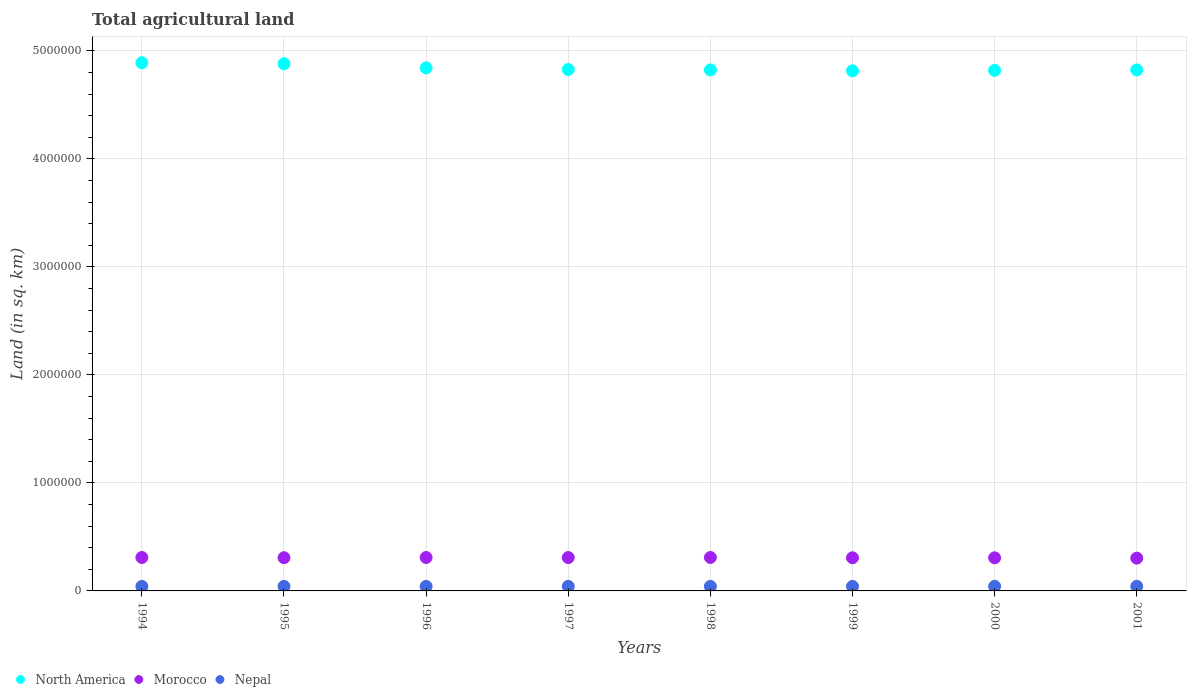How many different coloured dotlines are there?
Offer a terse response. 3. What is the total agricultural land in Nepal in 1997?
Offer a terse response. 4.21e+04. Across all years, what is the maximum total agricultural land in Morocco?
Offer a very short reply. 3.10e+05. Across all years, what is the minimum total agricultural land in Nepal?
Make the answer very short. 4.18e+04. What is the total total agricultural land in Morocco in the graph?
Ensure brevity in your answer.  2.46e+06. What is the difference between the total agricultural land in North America in 1996 and that in 1999?
Offer a very short reply. 2.75e+04. What is the difference between the total agricultural land in North America in 1994 and the total agricultural land in Nepal in 1996?
Your response must be concise. 4.85e+06. What is the average total agricultural land in Morocco per year?
Your answer should be compact. 3.08e+05. In the year 1998, what is the difference between the total agricultural land in North America and total agricultural land in Morocco?
Ensure brevity in your answer.  4.51e+06. What is the ratio of the total agricultural land in North America in 1995 to that in 1997?
Ensure brevity in your answer.  1.01. What is the difference between the highest and the second highest total agricultural land in Nepal?
Your response must be concise. 119. What is the difference between the highest and the lowest total agricultural land in North America?
Make the answer very short. 7.46e+04. In how many years, is the total agricultural land in Morocco greater than the average total agricultural land in Morocco taken over all years?
Provide a short and direct response. 4. Is the sum of the total agricultural land in Nepal in 1997 and 1999 greater than the maximum total agricultural land in North America across all years?
Make the answer very short. No. Is the total agricultural land in Morocco strictly greater than the total agricultural land in North America over the years?
Your response must be concise. No. How many years are there in the graph?
Your answer should be very brief. 8. What is the difference between two consecutive major ticks on the Y-axis?
Provide a short and direct response. 1.00e+06. Are the values on the major ticks of Y-axis written in scientific E-notation?
Your answer should be very brief. No. Does the graph contain grids?
Ensure brevity in your answer.  Yes. How are the legend labels stacked?
Provide a short and direct response. Horizontal. What is the title of the graph?
Ensure brevity in your answer.  Total agricultural land. Does "Qatar" appear as one of the legend labels in the graph?
Make the answer very short. No. What is the label or title of the X-axis?
Your answer should be compact. Years. What is the label or title of the Y-axis?
Keep it short and to the point. Land (in sq. km). What is the Land (in sq. km) of North America in 1994?
Provide a succinct answer. 4.89e+06. What is the Land (in sq. km) of Morocco in 1994?
Your answer should be very brief. 3.10e+05. What is the Land (in sq. km) in Nepal in 1994?
Ensure brevity in your answer.  4.18e+04. What is the Land (in sq. km) of North America in 1995?
Give a very brief answer. 4.88e+06. What is the Land (in sq. km) of Morocco in 1995?
Your answer should be compact. 3.07e+05. What is the Land (in sq. km) of Nepal in 1995?
Provide a short and direct response. 4.19e+04. What is the Land (in sq. km) of North America in 1996?
Your answer should be compact. 4.84e+06. What is the Land (in sq. km) in Morocco in 1996?
Keep it short and to the point. 3.10e+05. What is the Land (in sq. km) in Nepal in 1996?
Offer a very short reply. 4.20e+04. What is the Land (in sq. km) of North America in 1997?
Ensure brevity in your answer.  4.83e+06. What is the Land (in sq. km) in Morocco in 1997?
Offer a very short reply. 3.09e+05. What is the Land (in sq. km) in Nepal in 1997?
Provide a succinct answer. 4.21e+04. What is the Land (in sq. km) of North America in 1998?
Your answer should be very brief. 4.82e+06. What is the Land (in sq. km) of Morocco in 1998?
Give a very brief answer. 3.10e+05. What is the Land (in sq. km) of Nepal in 1998?
Your answer should be very brief. 4.23e+04. What is the Land (in sq. km) of North America in 1999?
Provide a short and direct response. 4.82e+06. What is the Land (in sq. km) of Morocco in 1999?
Make the answer very short. 3.07e+05. What is the Land (in sq. km) of Nepal in 1999?
Offer a very short reply. 4.24e+04. What is the Land (in sq. km) of North America in 2000?
Offer a very short reply. 4.82e+06. What is the Land (in sq. km) of Morocco in 2000?
Offer a terse response. 3.07e+05. What is the Land (in sq. km) in Nepal in 2000?
Your answer should be very brief. 4.25e+04. What is the Land (in sq. km) in North America in 2001?
Provide a short and direct response. 4.82e+06. What is the Land (in sq. km) in Morocco in 2001?
Your answer should be compact. 3.04e+05. What is the Land (in sq. km) of Nepal in 2001?
Your response must be concise. 4.26e+04. Across all years, what is the maximum Land (in sq. km) of North America?
Offer a very short reply. 4.89e+06. Across all years, what is the maximum Land (in sq. km) of Morocco?
Your answer should be compact. 3.10e+05. Across all years, what is the maximum Land (in sq. km) of Nepal?
Provide a succinct answer. 4.26e+04. Across all years, what is the minimum Land (in sq. km) of North America?
Make the answer very short. 4.82e+06. Across all years, what is the minimum Land (in sq. km) in Morocco?
Your answer should be compact. 3.04e+05. Across all years, what is the minimum Land (in sq. km) in Nepal?
Ensure brevity in your answer.  4.18e+04. What is the total Land (in sq. km) of North America in the graph?
Your answer should be very brief. 3.87e+07. What is the total Land (in sq. km) in Morocco in the graph?
Offer a terse response. 2.46e+06. What is the total Land (in sq. km) in Nepal in the graph?
Your answer should be very brief. 3.38e+05. What is the difference between the Land (in sq. km) in North America in 1994 and that in 1995?
Offer a terse response. 9399. What is the difference between the Land (in sq. km) of Morocco in 1994 and that in 1995?
Your answer should be very brief. 2150. What is the difference between the Land (in sq. km) in Nepal in 1994 and that in 1995?
Your answer should be very brief. -112. What is the difference between the Land (in sq. km) of North America in 1994 and that in 1996?
Provide a succinct answer. 4.71e+04. What is the difference between the Land (in sq. km) of Nepal in 1994 and that in 1996?
Offer a terse response. -224. What is the difference between the Land (in sq. km) in North America in 1994 and that in 1997?
Keep it short and to the point. 6.24e+04. What is the difference between the Land (in sq. km) of Morocco in 1994 and that in 1997?
Give a very brief answer. 690. What is the difference between the Land (in sq. km) of Nepal in 1994 and that in 1997?
Your answer should be very brief. -336. What is the difference between the Land (in sq. km) in North America in 1994 and that in 1998?
Your answer should be compact. 6.65e+04. What is the difference between the Land (in sq. km) in Morocco in 1994 and that in 1998?
Offer a very short reply. -120. What is the difference between the Land (in sq. km) in Nepal in 1994 and that in 1998?
Provide a succinct answer. -448. What is the difference between the Land (in sq. km) of North America in 1994 and that in 1999?
Your response must be concise. 7.46e+04. What is the difference between the Land (in sq. km) of Morocco in 1994 and that in 1999?
Your answer should be compact. 2710. What is the difference between the Land (in sq. km) of Nepal in 1994 and that in 1999?
Make the answer very short. -560. What is the difference between the Land (in sq. km) of North America in 1994 and that in 2000?
Offer a terse response. 7.06e+04. What is the difference between the Land (in sq. km) of Morocco in 1994 and that in 2000?
Keep it short and to the point. 3120. What is the difference between the Land (in sq. km) in Nepal in 1994 and that in 2000?
Make the answer very short. -685. What is the difference between the Land (in sq. km) in North America in 1994 and that in 2001?
Offer a very short reply. 6.63e+04. What is the difference between the Land (in sq. km) in Morocco in 1994 and that in 2001?
Offer a terse response. 5940. What is the difference between the Land (in sq. km) in Nepal in 1994 and that in 2001?
Your answer should be compact. -804. What is the difference between the Land (in sq. km) of North America in 1995 and that in 1996?
Offer a very short reply. 3.77e+04. What is the difference between the Land (in sq. km) of Morocco in 1995 and that in 1996?
Your answer should be very brief. -2170. What is the difference between the Land (in sq. km) in Nepal in 1995 and that in 1996?
Offer a terse response. -112. What is the difference between the Land (in sq. km) in North America in 1995 and that in 1997?
Your answer should be very brief. 5.30e+04. What is the difference between the Land (in sq. km) of Morocco in 1995 and that in 1997?
Offer a terse response. -1460. What is the difference between the Land (in sq. km) in Nepal in 1995 and that in 1997?
Your answer should be compact. -224. What is the difference between the Land (in sq. km) in North America in 1995 and that in 1998?
Ensure brevity in your answer.  5.71e+04. What is the difference between the Land (in sq. km) of Morocco in 1995 and that in 1998?
Offer a terse response. -2270. What is the difference between the Land (in sq. km) in Nepal in 1995 and that in 1998?
Give a very brief answer. -336. What is the difference between the Land (in sq. km) in North America in 1995 and that in 1999?
Provide a succinct answer. 6.52e+04. What is the difference between the Land (in sq. km) of Morocco in 1995 and that in 1999?
Offer a very short reply. 560. What is the difference between the Land (in sq. km) of Nepal in 1995 and that in 1999?
Ensure brevity in your answer.  -448. What is the difference between the Land (in sq. km) in North America in 1995 and that in 2000?
Offer a terse response. 6.12e+04. What is the difference between the Land (in sq. km) of Morocco in 1995 and that in 2000?
Make the answer very short. 970. What is the difference between the Land (in sq. km) of Nepal in 1995 and that in 2000?
Provide a short and direct response. -573. What is the difference between the Land (in sq. km) of North America in 1995 and that in 2001?
Ensure brevity in your answer.  5.69e+04. What is the difference between the Land (in sq. km) of Morocco in 1995 and that in 2001?
Ensure brevity in your answer.  3790. What is the difference between the Land (in sq. km) in Nepal in 1995 and that in 2001?
Give a very brief answer. -692. What is the difference between the Land (in sq. km) of North America in 1996 and that in 1997?
Offer a very short reply. 1.53e+04. What is the difference between the Land (in sq. km) of Morocco in 1996 and that in 1997?
Provide a succinct answer. 710. What is the difference between the Land (in sq. km) of Nepal in 1996 and that in 1997?
Your answer should be compact. -112. What is the difference between the Land (in sq. km) in North America in 1996 and that in 1998?
Provide a short and direct response. 1.94e+04. What is the difference between the Land (in sq. km) in Morocco in 1996 and that in 1998?
Your answer should be compact. -100. What is the difference between the Land (in sq. km) of Nepal in 1996 and that in 1998?
Your answer should be very brief. -224. What is the difference between the Land (in sq. km) in North America in 1996 and that in 1999?
Make the answer very short. 2.75e+04. What is the difference between the Land (in sq. km) of Morocco in 1996 and that in 1999?
Your response must be concise. 2730. What is the difference between the Land (in sq. km) in Nepal in 1996 and that in 1999?
Offer a very short reply. -336. What is the difference between the Land (in sq. km) of North America in 1996 and that in 2000?
Your answer should be very brief. 2.35e+04. What is the difference between the Land (in sq. km) in Morocco in 1996 and that in 2000?
Offer a terse response. 3140. What is the difference between the Land (in sq. km) in Nepal in 1996 and that in 2000?
Keep it short and to the point. -461. What is the difference between the Land (in sq. km) of North America in 1996 and that in 2001?
Ensure brevity in your answer.  1.92e+04. What is the difference between the Land (in sq. km) in Morocco in 1996 and that in 2001?
Give a very brief answer. 5960. What is the difference between the Land (in sq. km) of Nepal in 1996 and that in 2001?
Offer a terse response. -580. What is the difference between the Land (in sq. km) of North America in 1997 and that in 1998?
Make the answer very short. 4070. What is the difference between the Land (in sq. km) of Morocco in 1997 and that in 1998?
Make the answer very short. -810. What is the difference between the Land (in sq. km) in Nepal in 1997 and that in 1998?
Provide a succinct answer. -112. What is the difference between the Land (in sq. km) in North America in 1997 and that in 1999?
Keep it short and to the point. 1.22e+04. What is the difference between the Land (in sq. km) in Morocco in 1997 and that in 1999?
Your answer should be very brief. 2020. What is the difference between the Land (in sq. km) of Nepal in 1997 and that in 1999?
Provide a short and direct response. -224. What is the difference between the Land (in sq. km) in North America in 1997 and that in 2000?
Provide a short and direct response. 8170. What is the difference between the Land (in sq. km) of Morocco in 1997 and that in 2000?
Make the answer very short. 2430. What is the difference between the Land (in sq. km) in Nepal in 1997 and that in 2000?
Your answer should be very brief. -349. What is the difference between the Land (in sq. km) in North America in 1997 and that in 2001?
Offer a terse response. 3830. What is the difference between the Land (in sq. km) of Morocco in 1997 and that in 2001?
Provide a succinct answer. 5250. What is the difference between the Land (in sq. km) in Nepal in 1997 and that in 2001?
Your response must be concise. -468. What is the difference between the Land (in sq. km) in North America in 1998 and that in 1999?
Provide a succinct answer. 8120. What is the difference between the Land (in sq. km) of Morocco in 1998 and that in 1999?
Ensure brevity in your answer.  2830. What is the difference between the Land (in sq. km) of Nepal in 1998 and that in 1999?
Provide a succinct answer. -112. What is the difference between the Land (in sq. km) in North America in 1998 and that in 2000?
Keep it short and to the point. 4100. What is the difference between the Land (in sq. km) in Morocco in 1998 and that in 2000?
Provide a succinct answer. 3240. What is the difference between the Land (in sq. km) of Nepal in 1998 and that in 2000?
Ensure brevity in your answer.  -237. What is the difference between the Land (in sq. km) of North America in 1998 and that in 2001?
Give a very brief answer. -240. What is the difference between the Land (in sq. km) of Morocco in 1998 and that in 2001?
Provide a succinct answer. 6060. What is the difference between the Land (in sq. km) in Nepal in 1998 and that in 2001?
Offer a terse response. -356. What is the difference between the Land (in sq. km) in North America in 1999 and that in 2000?
Give a very brief answer. -4020. What is the difference between the Land (in sq. km) of Morocco in 1999 and that in 2000?
Give a very brief answer. 410. What is the difference between the Land (in sq. km) of Nepal in 1999 and that in 2000?
Offer a terse response. -125. What is the difference between the Land (in sq. km) of North America in 1999 and that in 2001?
Offer a very short reply. -8360. What is the difference between the Land (in sq. km) in Morocco in 1999 and that in 2001?
Offer a very short reply. 3230. What is the difference between the Land (in sq. km) of Nepal in 1999 and that in 2001?
Ensure brevity in your answer.  -244. What is the difference between the Land (in sq. km) of North America in 2000 and that in 2001?
Give a very brief answer. -4340. What is the difference between the Land (in sq. km) of Morocco in 2000 and that in 2001?
Offer a very short reply. 2820. What is the difference between the Land (in sq. km) of Nepal in 2000 and that in 2001?
Ensure brevity in your answer.  -119. What is the difference between the Land (in sq. km) of North America in 1994 and the Land (in sq. km) of Morocco in 1995?
Ensure brevity in your answer.  4.58e+06. What is the difference between the Land (in sq. km) in North America in 1994 and the Land (in sq. km) in Nepal in 1995?
Your response must be concise. 4.85e+06. What is the difference between the Land (in sq. km) of Morocco in 1994 and the Land (in sq. km) of Nepal in 1995?
Offer a very short reply. 2.68e+05. What is the difference between the Land (in sq. km) of North America in 1994 and the Land (in sq. km) of Morocco in 1996?
Offer a very short reply. 4.58e+06. What is the difference between the Land (in sq. km) of North America in 1994 and the Land (in sq. km) of Nepal in 1996?
Offer a terse response. 4.85e+06. What is the difference between the Land (in sq. km) of Morocco in 1994 and the Land (in sq. km) of Nepal in 1996?
Offer a very short reply. 2.68e+05. What is the difference between the Land (in sq. km) of North America in 1994 and the Land (in sq. km) of Morocco in 1997?
Offer a very short reply. 4.58e+06. What is the difference between the Land (in sq. km) of North America in 1994 and the Land (in sq. km) of Nepal in 1997?
Provide a succinct answer. 4.85e+06. What is the difference between the Land (in sq. km) of Morocco in 1994 and the Land (in sq. km) of Nepal in 1997?
Keep it short and to the point. 2.67e+05. What is the difference between the Land (in sq. km) of North America in 1994 and the Land (in sq. km) of Morocco in 1998?
Provide a succinct answer. 4.58e+06. What is the difference between the Land (in sq. km) of North America in 1994 and the Land (in sq. km) of Nepal in 1998?
Your answer should be very brief. 4.85e+06. What is the difference between the Land (in sq. km) in Morocco in 1994 and the Land (in sq. km) in Nepal in 1998?
Your response must be concise. 2.67e+05. What is the difference between the Land (in sq. km) in North America in 1994 and the Land (in sq. km) in Morocco in 1999?
Offer a very short reply. 4.58e+06. What is the difference between the Land (in sq. km) of North America in 1994 and the Land (in sq. km) of Nepal in 1999?
Your answer should be very brief. 4.85e+06. What is the difference between the Land (in sq. km) in Morocco in 1994 and the Land (in sq. km) in Nepal in 1999?
Ensure brevity in your answer.  2.67e+05. What is the difference between the Land (in sq. km) of North America in 1994 and the Land (in sq. km) of Morocco in 2000?
Offer a terse response. 4.58e+06. What is the difference between the Land (in sq. km) of North America in 1994 and the Land (in sq. km) of Nepal in 2000?
Offer a very short reply. 4.85e+06. What is the difference between the Land (in sq. km) of Morocco in 1994 and the Land (in sq. km) of Nepal in 2000?
Give a very brief answer. 2.67e+05. What is the difference between the Land (in sq. km) in North America in 1994 and the Land (in sq. km) in Morocco in 2001?
Ensure brevity in your answer.  4.59e+06. What is the difference between the Land (in sq. km) in North America in 1994 and the Land (in sq. km) in Nepal in 2001?
Give a very brief answer. 4.85e+06. What is the difference between the Land (in sq. km) of Morocco in 1994 and the Land (in sq. km) of Nepal in 2001?
Offer a terse response. 2.67e+05. What is the difference between the Land (in sq. km) in North America in 1995 and the Land (in sq. km) in Morocco in 1996?
Ensure brevity in your answer.  4.57e+06. What is the difference between the Land (in sq. km) of North America in 1995 and the Land (in sq. km) of Nepal in 1996?
Give a very brief answer. 4.84e+06. What is the difference between the Land (in sq. km) in Morocco in 1995 and the Land (in sq. km) in Nepal in 1996?
Your answer should be compact. 2.65e+05. What is the difference between the Land (in sq. km) in North America in 1995 and the Land (in sq. km) in Morocco in 1997?
Ensure brevity in your answer.  4.57e+06. What is the difference between the Land (in sq. km) of North America in 1995 and the Land (in sq. km) of Nepal in 1997?
Offer a very short reply. 4.84e+06. What is the difference between the Land (in sq. km) of Morocco in 1995 and the Land (in sq. km) of Nepal in 1997?
Your answer should be compact. 2.65e+05. What is the difference between the Land (in sq. km) in North America in 1995 and the Land (in sq. km) in Morocco in 1998?
Offer a terse response. 4.57e+06. What is the difference between the Land (in sq. km) of North America in 1995 and the Land (in sq. km) of Nepal in 1998?
Your response must be concise. 4.84e+06. What is the difference between the Land (in sq. km) in Morocco in 1995 and the Land (in sq. km) in Nepal in 1998?
Your answer should be compact. 2.65e+05. What is the difference between the Land (in sq. km) of North America in 1995 and the Land (in sq. km) of Morocco in 1999?
Offer a very short reply. 4.57e+06. What is the difference between the Land (in sq. km) of North America in 1995 and the Land (in sq. km) of Nepal in 1999?
Your response must be concise. 4.84e+06. What is the difference between the Land (in sq. km) of Morocco in 1995 and the Land (in sq. km) of Nepal in 1999?
Ensure brevity in your answer.  2.65e+05. What is the difference between the Land (in sq. km) of North America in 1995 and the Land (in sq. km) of Morocco in 2000?
Make the answer very short. 4.57e+06. What is the difference between the Land (in sq. km) in North America in 1995 and the Land (in sq. km) in Nepal in 2000?
Your response must be concise. 4.84e+06. What is the difference between the Land (in sq. km) in Morocco in 1995 and the Land (in sq. km) in Nepal in 2000?
Ensure brevity in your answer.  2.65e+05. What is the difference between the Land (in sq. km) in North America in 1995 and the Land (in sq. km) in Morocco in 2001?
Ensure brevity in your answer.  4.58e+06. What is the difference between the Land (in sq. km) in North America in 1995 and the Land (in sq. km) in Nepal in 2001?
Keep it short and to the point. 4.84e+06. What is the difference between the Land (in sq. km) of Morocco in 1995 and the Land (in sq. km) of Nepal in 2001?
Make the answer very short. 2.65e+05. What is the difference between the Land (in sq. km) of North America in 1996 and the Land (in sq. km) of Morocco in 1997?
Give a very brief answer. 4.53e+06. What is the difference between the Land (in sq. km) in North America in 1996 and the Land (in sq. km) in Nepal in 1997?
Provide a succinct answer. 4.80e+06. What is the difference between the Land (in sq. km) in Morocco in 1996 and the Land (in sq. km) in Nepal in 1997?
Your answer should be very brief. 2.68e+05. What is the difference between the Land (in sq. km) in North America in 1996 and the Land (in sq. km) in Morocco in 1998?
Your answer should be compact. 4.53e+06. What is the difference between the Land (in sq. km) in North America in 1996 and the Land (in sq. km) in Nepal in 1998?
Your answer should be compact. 4.80e+06. What is the difference between the Land (in sq. km) in Morocco in 1996 and the Land (in sq. km) in Nepal in 1998?
Keep it short and to the point. 2.67e+05. What is the difference between the Land (in sq. km) of North America in 1996 and the Land (in sq. km) of Morocco in 1999?
Your answer should be very brief. 4.54e+06. What is the difference between the Land (in sq. km) of North America in 1996 and the Land (in sq. km) of Nepal in 1999?
Make the answer very short. 4.80e+06. What is the difference between the Land (in sq. km) of Morocco in 1996 and the Land (in sq. km) of Nepal in 1999?
Your answer should be very brief. 2.67e+05. What is the difference between the Land (in sq. km) of North America in 1996 and the Land (in sq. km) of Morocco in 2000?
Keep it short and to the point. 4.54e+06. What is the difference between the Land (in sq. km) of North America in 1996 and the Land (in sq. km) of Nepal in 2000?
Ensure brevity in your answer.  4.80e+06. What is the difference between the Land (in sq. km) in Morocco in 1996 and the Land (in sq. km) in Nepal in 2000?
Your answer should be compact. 2.67e+05. What is the difference between the Land (in sq. km) in North America in 1996 and the Land (in sq. km) in Morocco in 2001?
Your answer should be compact. 4.54e+06. What is the difference between the Land (in sq. km) of North America in 1996 and the Land (in sq. km) of Nepal in 2001?
Ensure brevity in your answer.  4.80e+06. What is the difference between the Land (in sq. km) of Morocco in 1996 and the Land (in sq. km) of Nepal in 2001?
Offer a terse response. 2.67e+05. What is the difference between the Land (in sq. km) in North America in 1997 and the Land (in sq. km) in Morocco in 1998?
Keep it short and to the point. 4.52e+06. What is the difference between the Land (in sq. km) of North America in 1997 and the Land (in sq. km) of Nepal in 1998?
Your response must be concise. 4.79e+06. What is the difference between the Land (in sq. km) of Morocco in 1997 and the Land (in sq. km) of Nepal in 1998?
Give a very brief answer. 2.67e+05. What is the difference between the Land (in sq. km) of North America in 1997 and the Land (in sq. km) of Morocco in 1999?
Your answer should be very brief. 4.52e+06. What is the difference between the Land (in sq. km) in North America in 1997 and the Land (in sq. km) in Nepal in 1999?
Your response must be concise. 4.79e+06. What is the difference between the Land (in sq. km) of Morocco in 1997 and the Land (in sq. km) of Nepal in 1999?
Keep it short and to the point. 2.67e+05. What is the difference between the Land (in sq. km) of North America in 1997 and the Land (in sq. km) of Morocco in 2000?
Keep it short and to the point. 4.52e+06. What is the difference between the Land (in sq. km) in North America in 1997 and the Land (in sq. km) in Nepal in 2000?
Offer a terse response. 4.79e+06. What is the difference between the Land (in sq. km) in Morocco in 1997 and the Land (in sq. km) in Nepal in 2000?
Offer a very short reply. 2.66e+05. What is the difference between the Land (in sq. km) in North America in 1997 and the Land (in sq. km) in Morocco in 2001?
Your answer should be compact. 4.52e+06. What is the difference between the Land (in sq. km) in North America in 1997 and the Land (in sq. km) in Nepal in 2001?
Give a very brief answer. 4.79e+06. What is the difference between the Land (in sq. km) in Morocco in 1997 and the Land (in sq. km) in Nepal in 2001?
Ensure brevity in your answer.  2.66e+05. What is the difference between the Land (in sq. km) in North America in 1998 and the Land (in sq. km) in Morocco in 1999?
Give a very brief answer. 4.52e+06. What is the difference between the Land (in sq. km) of North America in 1998 and the Land (in sq. km) of Nepal in 1999?
Ensure brevity in your answer.  4.78e+06. What is the difference between the Land (in sq. km) of Morocco in 1998 and the Land (in sq. km) of Nepal in 1999?
Give a very brief answer. 2.67e+05. What is the difference between the Land (in sq. km) of North America in 1998 and the Land (in sq. km) of Morocco in 2000?
Offer a very short reply. 4.52e+06. What is the difference between the Land (in sq. km) in North America in 1998 and the Land (in sq. km) in Nepal in 2000?
Keep it short and to the point. 4.78e+06. What is the difference between the Land (in sq. km) in Morocco in 1998 and the Land (in sq. km) in Nepal in 2000?
Your answer should be compact. 2.67e+05. What is the difference between the Land (in sq. km) of North America in 1998 and the Land (in sq. km) of Morocco in 2001?
Keep it short and to the point. 4.52e+06. What is the difference between the Land (in sq. km) of North America in 1998 and the Land (in sq. km) of Nepal in 2001?
Provide a succinct answer. 4.78e+06. What is the difference between the Land (in sq. km) of Morocco in 1998 and the Land (in sq. km) of Nepal in 2001?
Provide a succinct answer. 2.67e+05. What is the difference between the Land (in sq. km) in North America in 1999 and the Land (in sq. km) in Morocco in 2000?
Offer a very short reply. 4.51e+06. What is the difference between the Land (in sq. km) in North America in 1999 and the Land (in sq. km) in Nepal in 2000?
Provide a short and direct response. 4.77e+06. What is the difference between the Land (in sq. km) in Morocco in 1999 and the Land (in sq. km) in Nepal in 2000?
Make the answer very short. 2.64e+05. What is the difference between the Land (in sq. km) of North America in 1999 and the Land (in sq. km) of Morocco in 2001?
Your answer should be compact. 4.51e+06. What is the difference between the Land (in sq. km) in North America in 1999 and the Land (in sq. km) in Nepal in 2001?
Your answer should be compact. 4.77e+06. What is the difference between the Land (in sq. km) of Morocco in 1999 and the Land (in sq. km) of Nepal in 2001?
Offer a very short reply. 2.64e+05. What is the difference between the Land (in sq. km) in North America in 2000 and the Land (in sq. km) in Morocco in 2001?
Keep it short and to the point. 4.52e+06. What is the difference between the Land (in sq. km) in North America in 2000 and the Land (in sq. km) in Nepal in 2001?
Make the answer very short. 4.78e+06. What is the difference between the Land (in sq. km) in Morocco in 2000 and the Land (in sq. km) in Nepal in 2001?
Keep it short and to the point. 2.64e+05. What is the average Land (in sq. km) in North America per year?
Your answer should be compact. 4.84e+06. What is the average Land (in sq. km) of Morocco per year?
Offer a terse response. 3.08e+05. What is the average Land (in sq. km) of Nepal per year?
Provide a succinct answer. 4.22e+04. In the year 1994, what is the difference between the Land (in sq. km) of North America and Land (in sq. km) of Morocco?
Keep it short and to the point. 4.58e+06. In the year 1994, what is the difference between the Land (in sq. km) of North America and Land (in sq. km) of Nepal?
Give a very brief answer. 4.85e+06. In the year 1994, what is the difference between the Land (in sq. km) of Morocco and Land (in sq. km) of Nepal?
Your answer should be very brief. 2.68e+05. In the year 1995, what is the difference between the Land (in sq. km) in North America and Land (in sq. km) in Morocco?
Offer a very short reply. 4.57e+06. In the year 1995, what is the difference between the Land (in sq. km) in North America and Land (in sq. km) in Nepal?
Make the answer very short. 4.84e+06. In the year 1995, what is the difference between the Land (in sq. km) in Morocco and Land (in sq. km) in Nepal?
Give a very brief answer. 2.66e+05. In the year 1996, what is the difference between the Land (in sq. km) in North America and Land (in sq. km) in Morocco?
Ensure brevity in your answer.  4.53e+06. In the year 1996, what is the difference between the Land (in sq. km) in North America and Land (in sq. km) in Nepal?
Offer a very short reply. 4.80e+06. In the year 1996, what is the difference between the Land (in sq. km) of Morocco and Land (in sq. km) of Nepal?
Make the answer very short. 2.68e+05. In the year 1997, what is the difference between the Land (in sq. km) in North America and Land (in sq. km) in Morocco?
Provide a succinct answer. 4.52e+06. In the year 1997, what is the difference between the Land (in sq. km) in North America and Land (in sq. km) in Nepal?
Ensure brevity in your answer.  4.79e+06. In the year 1997, what is the difference between the Land (in sq. km) of Morocco and Land (in sq. km) of Nepal?
Give a very brief answer. 2.67e+05. In the year 1998, what is the difference between the Land (in sq. km) of North America and Land (in sq. km) of Morocco?
Your answer should be very brief. 4.51e+06. In the year 1998, what is the difference between the Land (in sq. km) of North America and Land (in sq. km) of Nepal?
Offer a very short reply. 4.78e+06. In the year 1998, what is the difference between the Land (in sq. km) in Morocco and Land (in sq. km) in Nepal?
Your answer should be very brief. 2.68e+05. In the year 1999, what is the difference between the Land (in sq. km) in North America and Land (in sq. km) in Morocco?
Make the answer very short. 4.51e+06. In the year 1999, what is the difference between the Land (in sq. km) in North America and Land (in sq. km) in Nepal?
Provide a short and direct response. 4.77e+06. In the year 1999, what is the difference between the Land (in sq. km) in Morocco and Land (in sq. km) in Nepal?
Your answer should be compact. 2.65e+05. In the year 2000, what is the difference between the Land (in sq. km) of North America and Land (in sq. km) of Morocco?
Offer a very short reply. 4.51e+06. In the year 2000, what is the difference between the Land (in sq. km) in North America and Land (in sq. km) in Nepal?
Your response must be concise. 4.78e+06. In the year 2000, what is the difference between the Land (in sq. km) in Morocco and Land (in sq. km) in Nepal?
Your answer should be compact. 2.64e+05. In the year 2001, what is the difference between the Land (in sq. km) of North America and Land (in sq. km) of Morocco?
Your answer should be very brief. 4.52e+06. In the year 2001, what is the difference between the Land (in sq. km) of North America and Land (in sq. km) of Nepal?
Your response must be concise. 4.78e+06. In the year 2001, what is the difference between the Land (in sq. km) in Morocco and Land (in sq. km) in Nepal?
Give a very brief answer. 2.61e+05. What is the ratio of the Land (in sq. km) of North America in 1994 to that in 1996?
Keep it short and to the point. 1.01. What is the ratio of the Land (in sq. km) in Morocco in 1994 to that in 1996?
Keep it short and to the point. 1. What is the ratio of the Land (in sq. km) in Nepal in 1994 to that in 1996?
Ensure brevity in your answer.  0.99. What is the ratio of the Land (in sq. km) in North America in 1994 to that in 1997?
Offer a very short reply. 1.01. What is the ratio of the Land (in sq. km) in Morocco in 1994 to that in 1997?
Give a very brief answer. 1. What is the ratio of the Land (in sq. km) of Nepal in 1994 to that in 1997?
Give a very brief answer. 0.99. What is the ratio of the Land (in sq. km) of North America in 1994 to that in 1998?
Provide a succinct answer. 1.01. What is the ratio of the Land (in sq. km) of North America in 1994 to that in 1999?
Provide a short and direct response. 1.02. What is the ratio of the Land (in sq. km) in Morocco in 1994 to that in 1999?
Provide a short and direct response. 1.01. What is the ratio of the Land (in sq. km) in Nepal in 1994 to that in 1999?
Provide a short and direct response. 0.99. What is the ratio of the Land (in sq. km) of North America in 1994 to that in 2000?
Make the answer very short. 1.01. What is the ratio of the Land (in sq. km) of Morocco in 1994 to that in 2000?
Give a very brief answer. 1.01. What is the ratio of the Land (in sq. km) of Nepal in 1994 to that in 2000?
Offer a terse response. 0.98. What is the ratio of the Land (in sq. km) of North America in 1994 to that in 2001?
Keep it short and to the point. 1.01. What is the ratio of the Land (in sq. km) in Morocco in 1994 to that in 2001?
Your response must be concise. 1.02. What is the ratio of the Land (in sq. km) in Nepal in 1994 to that in 2001?
Provide a short and direct response. 0.98. What is the ratio of the Land (in sq. km) in North America in 1995 to that in 1996?
Your response must be concise. 1.01. What is the ratio of the Land (in sq. km) of Morocco in 1995 to that in 1996?
Offer a terse response. 0.99. What is the ratio of the Land (in sq. km) of Nepal in 1995 to that in 1996?
Provide a succinct answer. 1. What is the ratio of the Land (in sq. km) in Morocco in 1995 to that in 1997?
Keep it short and to the point. 1. What is the ratio of the Land (in sq. km) in Nepal in 1995 to that in 1997?
Provide a succinct answer. 0.99. What is the ratio of the Land (in sq. km) of North America in 1995 to that in 1998?
Your answer should be compact. 1.01. What is the ratio of the Land (in sq. km) of Nepal in 1995 to that in 1998?
Offer a very short reply. 0.99. What is the ratio of the Land (in sq. km) in North America in 1995 to that in 1999?
Your answer should be very brief. 1.01. What is the ratio of the Land (in sq. km) of North America in 1995 to that in 2000?
Your answer should be compact. 1.01. What is the ratio of the Land (in sq. km) in Nepal in 1995 to that in 2000?
Your answer should be compact. 0.99. What is the ratio of the Land (in sq. km) of North America in 1995 to that in 2001?
Offer a terse response. 1.01. What is the ratio of the Land (in sq. km) of Morocco in 1995 to that in 2001?
Give a very brief answer. 1.01. What is the ratio of the Land (in sq. km) in Nepal in 1995 to that in 2001?
Make the answer very short. 0.98. What is the ratio of the Land (in sq. km) of North America in 1996 to that in 1997?
Make the answer very short. 1. What is the ratio of the Land (in sq. km) in Nepal in 1996 to that in 1998?
Your answer should be compact. 0.99. What is the ratio of the Land (in sq. km) in Morocco in 1996 to that in 1999?
Offer a very short reply. 1.01. What is the ratio of the Land (in sq. km) of Nepal in 1996 to that in 1999?
Make the answer very short. 0.99. What is the ratio of the Land (in sq. km) of Morocco in 1996 to that in 2000?
Offer a terse response. 1.01. What is the ratio of the Land (in sq. km) of Nepal in 1996 to that in 2000?
Provide a short and direct response. 0.99. What is the ratio of the Land (in sq. km) in Morocco in 1996 to that in 2001?
Offer a terse response. 1.02. What is the ratio of the Land (in sq. km) of Nepal in 1996 to that in 2001?
Keep it short and to the point. 0.99. What is the ratio of the Land (in sq. km) of Morocco in 1997 to that in 1999?
Ensure brevity in your answer.  1.01. What is the ratio of the Land (in sq. km) of Nepal in 1997 to that in 1999?
Provide a succinct answer. 0.99. What is the ratio of the Land (in sq. km) in North America in 1997 to that in 2000?
Ensure brevity in your answer.  1. What is the ratio of the Land (in sq. km) in Morocco in 1997 to that in 2000?
Your answer should be compact. 1.01. What is the ratio of the Land (in sq. km) in Nepal in 1997 to that in 2000?
Provide a short and direct response. 0.99. What is the ratio of the Land (in sq. km) of Morocco in 1997 to that in 2001?
Offer a terse response. 1.02. What is the ratio of the Land (in sq. km) in North America in 1998 to that in 1999?
Keep it short and to the point. 1. What is the ratio of the Land (in sq. km) of Morocco in 1998 to that in 1999?
Your answer should be compact. 1.01. What is the ratio of the Land (in sq. km) of Nepal in 1998 to that in 1999?
Your answer should be compact. 1. What is the ratio of the Land (in sq. km) in North America in 1998 to that in 2000?
Ensure brevity in your answer.  1. What is the ratio of the Land (in sq. km) of Morocco in 1998 to that in 2000?
Make the answer very short. 1.01. What is the ratio of the Land (in sq. km) of Nepal in 1998 to that in 2000?
Ensure brevity in your answer.  0.99. What is the ratio of the Land (in sq. km) in North America in 1998 to that in 2001?
Make the answer very short. 1. What is the ratio of the Land (in sq. km) in Morocco in 1998 to that in 2001?
Offer a very short reply. 1.02. What is the ratio of the Land (in sq. km) of North America in 1999 to that in 2000?
Keep it short and to the point. 1. What is the ratio of the Land (in sq. km) of Nepal in 1999 to that in 2000?
Make the answer very short. 1. What is the ratio of the Land (in sq. km) in North America in 1999 to that in 2001?
Provide a succinct answer. 1. What is the ratio of the Land (in sq. km) in Morocco in 1999 to that in 2001?
Provide a short and direct response. 1.01. What is the ratio of the Land (in sq. km) in Nepal in 1999 to that in 2001?
Your answer should be very brief. 0.99. What is the ratio of the Land (in sq. km) of Morocco in 2000 to that in 2001?
Ensure brevity in your answer.  1.01. What is the ratio of the Land (in sq. km) in Nepal in 2000 to that in 2001?
Keep it short and to the point. 1. What is the difference between the highest and the second highest Land (in sq. km) in North America?
Ensure brevity in your answer.  9399. What is the difference between the highest and the second highest Land (in sq. km) in Nepal?
Provide a succinct answer. 119. What is the difference between the highest and the lowest Land (in sq. km) in North America?
Keep it short and to the point. 7.46e+04. What is the difference between the highest and the lowest Land (in sq. km) of Morocco?
Give a very brief answer. 6060. What is the difference between the highest and the lowest Land (in sq. km) of Nepal?
Provide a short and direct response. 804. 